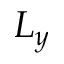Convert formula to latex. <formula><loc_0><loc_0><loc_500><loc_500>L _ { y }</formula> 